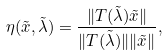<formula> <loc_0><loc_0><loc_500><loc_500>\eta ( \tilde { x } , \tilde { \lambda } ) = \frac { \| T ( \tilde { \lambda } ) \tilde { x } \| } { \| T ( \tilde { \lambda } ) \| \| \tilde { x } \| } ,</formula> 